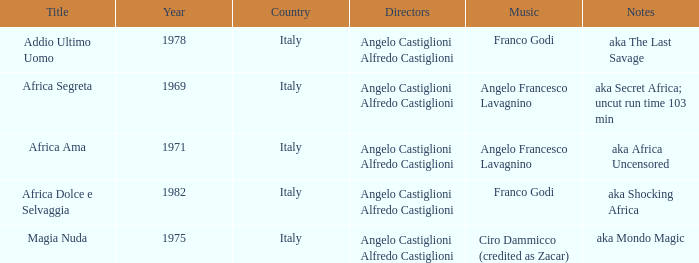How many years have a Title of Magia Nuda? 1.0. 